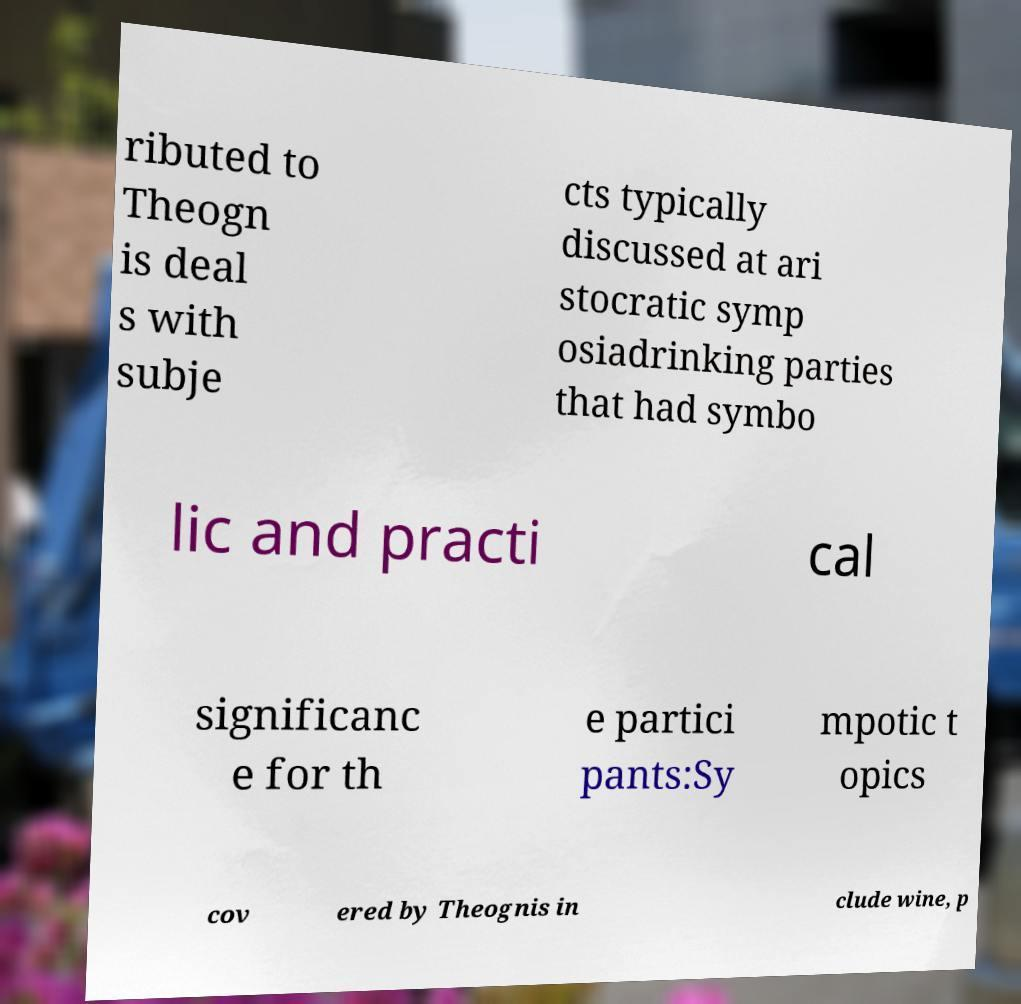Can you read and provide the text displayed in the image?This photo seems to have some interesting text. Can you extract and type it out for me? ributed to Theogn is deal s with subje cts typically discussed at ari stocratic symp osiadrinking parties that had symbo lic and practi cal significanc e for th e partici pants:Sy mpotic t opics cov ered by Theognis in clude wine, p 